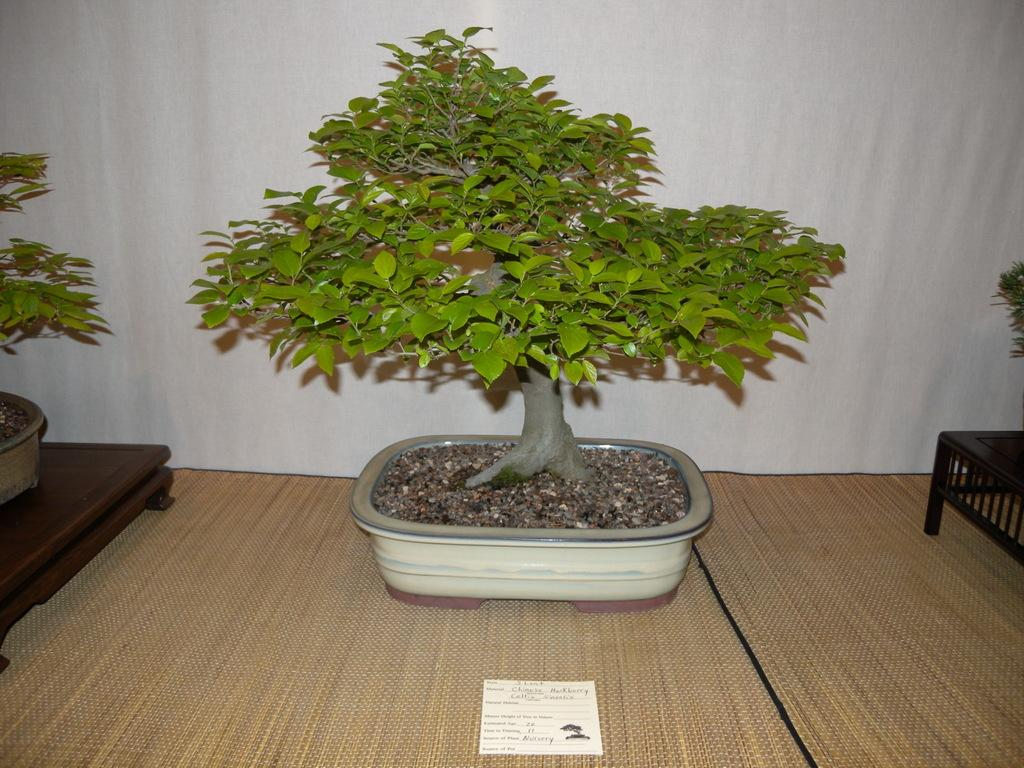What objects are present in the image related to plants? There are flowerpots in the image. How are some of the flowerpots positioned? Some flowerpots are on stands. Where is one flowerpot located in the image? One flowerpot is on a brown surface. What color is the background of the image? The background of the image is white. Can you see a cat sitting in front of the flowerpots in the image? There is no cat present in the image. What type of pear is placed on top of the flowerpot in the image? There are no pears present in the image; it only features flowerpots. 